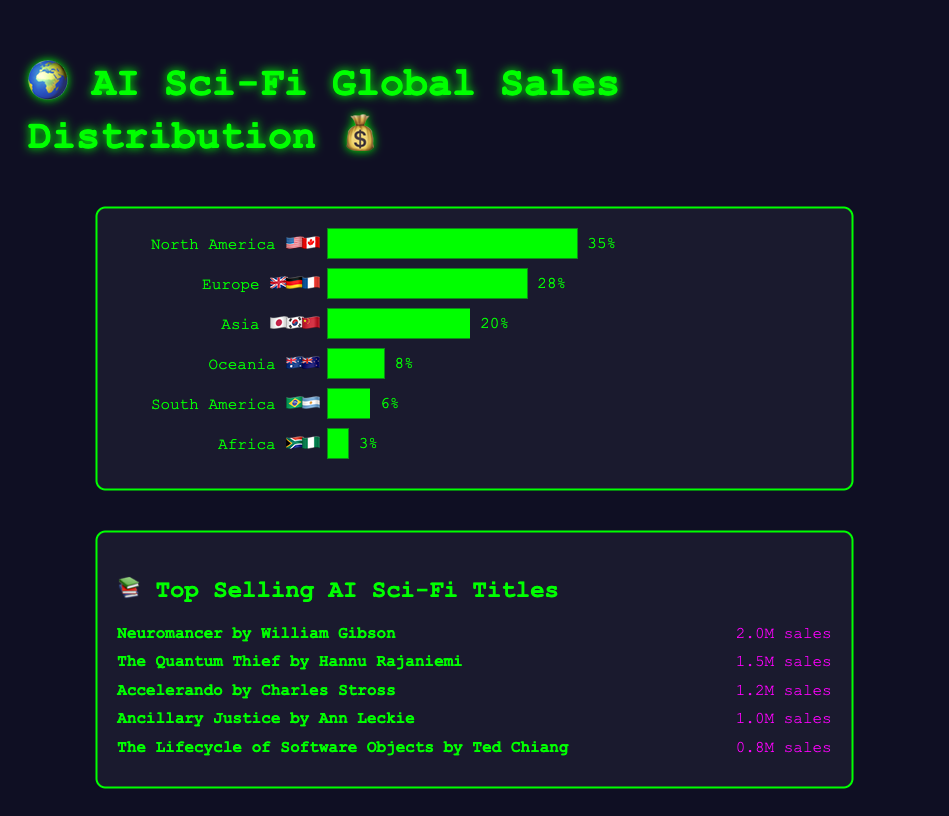What is the percentage of global sales in North America 🇺🇸🇨🇦? The figure shows a bar for North America 🇺🇸🇨🇦. The percentage value next to it is 35%.
Answer: 35% Which region has the second highest percentage of sales? By examining the bar chart, the highest percentage is North America 🇺🇸🇨🇦 with 35%, followed by Europe 🇬🇧🇩🇪🇫🇷 at 28%.
Answer: Europe 🇬🇧🇩🇪🇫🇷 What is the combined percentage of global sales for Asia 🇯🇵🇰🇷🇨🇳 and Oceania 🇦🇺🇳🇿? Adding the percentage of Asia 🇯🇵🇰🇷🇨🇳 (20%) and Oceania 🇦🇺🇳🇿 (8%), the combined percentage is 20% + 8% = 28%.
Answer: 28% Which region has the lowest percentage of global sales, and what is that percentage? The bar with the smallest length corresponds to Africa 🇿🇦🇳🇬, labeled with 3%.
Answer: Africa 🇿🇦🇳🇬, 3% Out of the top-selling book titles, which one has the highest sales? By checking the listed books, "Neuromancer" by William Gibson has the highest sales at 2 million.
Answer: Neuromancer How much higher are the sales of "The Quantum Thief" compared to "Ancillary Justice"? "The Quantum Thief" has sales of 1.5 million and "Ancillary Justice" has sales of 1 million. The difference is 1.5M - 1M = 0.5M.
Answer: 0.5 million What is the average sales figure for the top five AI Sci-Fi titles? Summing up the sales: 2000000 + 1500000 + 1200000 + 1000000 + 800000 = 6500000. Dividing by 5, the average is 6500000 / 5 = 1300000.
Answer: 1.3 million Compare the percentage of sales in Europe 🇬🇧🇩🇪🇫🇷 and Asia 🇯🇵🇰🇷🇨🇳? Europe 🇬🇧🇩🇪🇫🇷 has 28% of sales and Asia 🇯🇵🇰🇷🇨🇳 has 20%. Europe has 8% more sales than Asia.
Answer: Europe has 8% more How many more sales does "Neuromancer" have compared to "The Lifecycle of Software Objects"? "Neuromancer" has 2 million sales and "The Lifecycle of Software Objects" has 0.8 million. The difference is 2M - 0.8M = 1.2M.
Answer: 1.2 million Which region has a sales percentage closest to 10%? Oceania 🇦🇺🇳🇿 is the closest to 10% with 8%.
Answer: Oceania 🇦🇺🇳🇿 